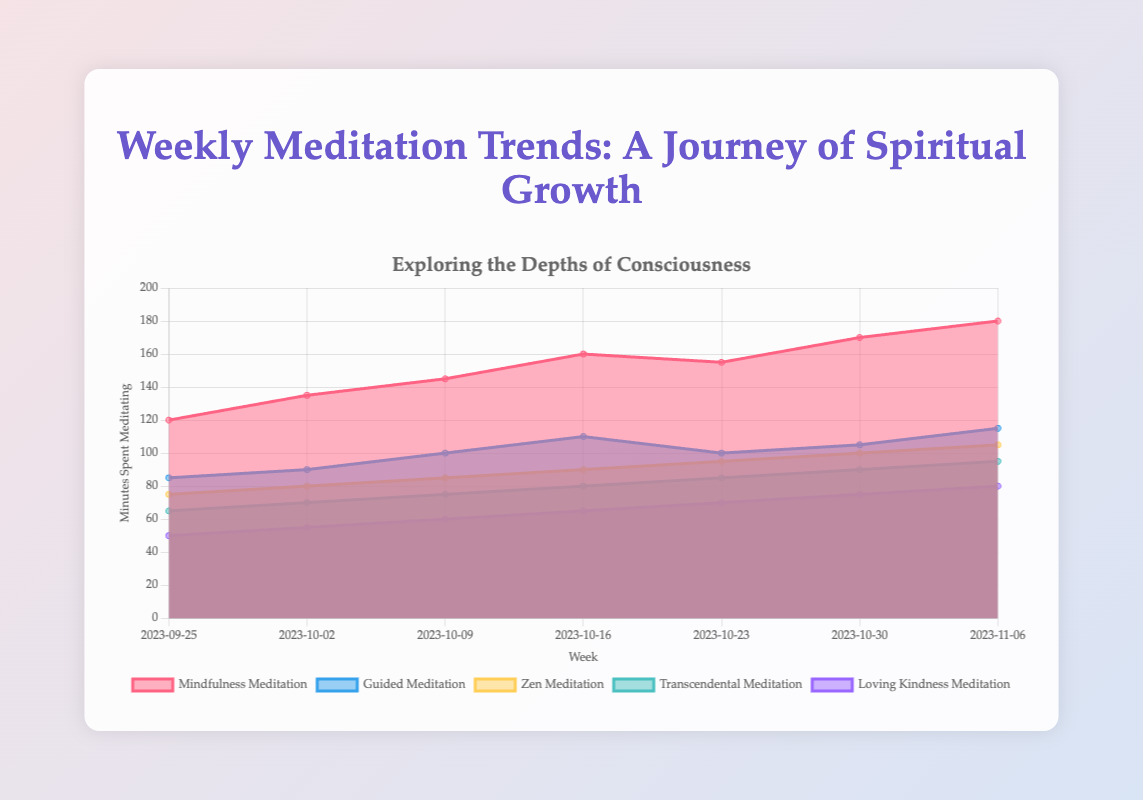What is the title of the chart? The title of the chart is located at the top and reads "Weekly Meditation Trends: A Journey of Spiritual Growth."
Answer: Weekly Meditation Trends: A Journey of Spiritual Growth What are the start and end dates on the x-axis? The x-axis represents weeks and starts at "2023-09-25" and ends at "2023-11-06."
Answer: 2023-09-25, 2023-11-06 What color represents "Zen Meditation" in the chart? The chart uses different colors for each meditation technique, and "Zen Meditation" is represented by a yellowish color.
Answer: Yellow How many more minutes were spent on "Mindfulness Meditation" than "Loving Kindness Meditation" during the week of 2023-10-30? In the week of 2023-10-30, "Mindfulness Meditation" is at 170 minutes, and "Loving Kindness Meditation" is at 75 minutes. The difference is 170 - 75 = 95 minutes.
Answer: 95 Which meditation technique shows the least amount of growth over the observed weeks? To determine the least growth, compare the start and end values of each meditation technique. "Transcendental Meditation" grows from 65 to 95, showing the smallest difference (30 minutes).
Answer: Transcendental Meditation What is the total number of minutes spent on "Guided Meditation" over the entire observed period? Sum the "Guided Meditation" values over all weeks: 85 + 90 + 100 + 110 + 100 + 105 + 115 = 705 minutes.
Answer: 705 Which meditation technique had its highest value at the final week (2023-11-06)? Observe the values in the final week: "Mindfulness Meditation" has 180, which is the highest among the techniques.
Answer: Mindfulness Meditation How much more time was spent on "Mindfulness Meditation" compared to "Zen Meditation" during the week of 2023-10-09? "Mindfulness Meditation" is at 145 minutes, and "Zen Meditation" is at 85 minutes during the week of 2023-10-09. The difference is 145 - 85 = 60 minutes.
Answer: 60 Rank the meditation techniques based on their total minutes spent over the entire period, from highest to lowest. Sum the total minutes for each technique across all weeks. "Mindfulness Meditation": 1065, "Guided Meditation": 705, "Zen Meditation": 630, "Transcendental Meditation": 560, "Loving Kindness Meditation": 455. The rank from highest to lowest is: Mindfulness, Guided, Zen, Transcendental, Loving Kindness.
Answer: Mindfulness, Guided, Zen, Transcendental, Loving Kindness 